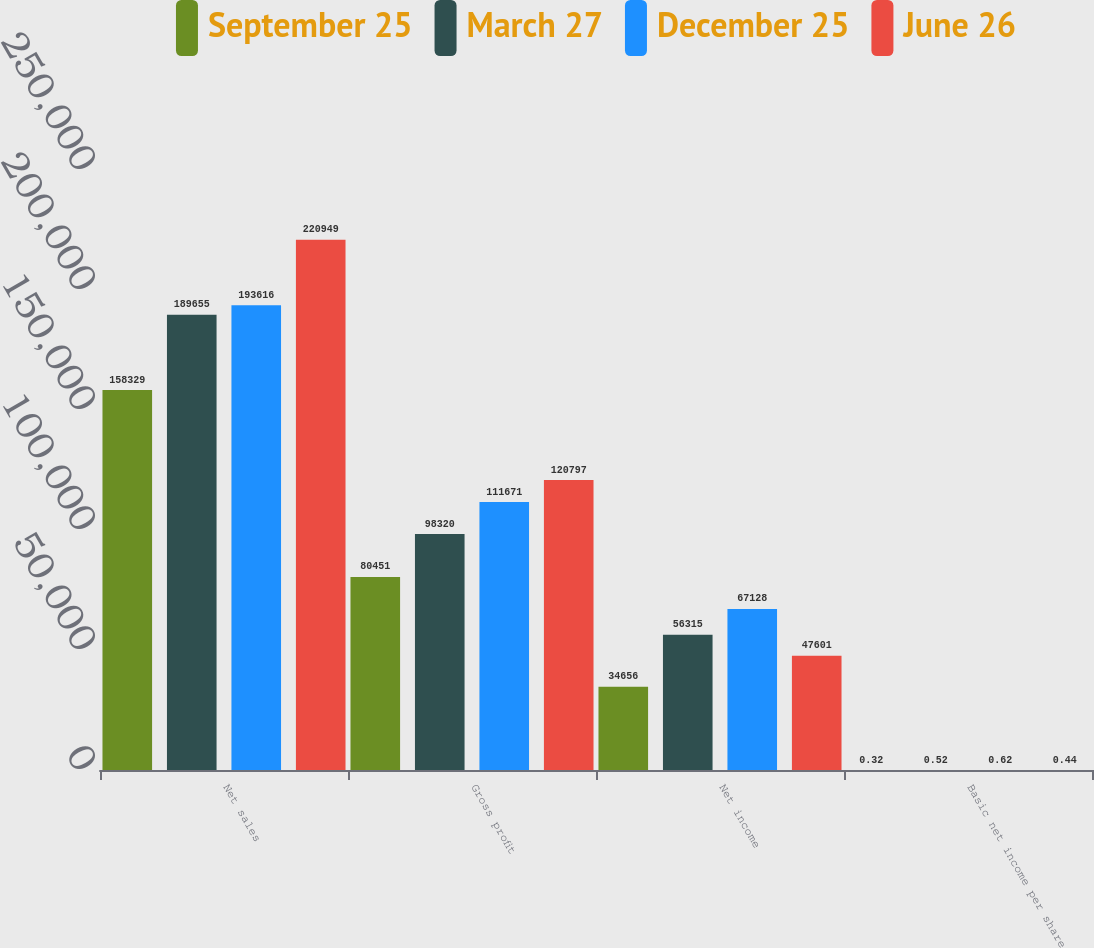Convert chart. <chart><loc_0><loc_0><loc_500><loc_500><stacked_bar_chart><ecel><fcel>Net sales<fcel>Gross profit<fcel>Net income<fcel>Basic net income per share<nl><fcel>September 25<fcel>158329<fcel>80451<fcel>34656<fcel>0.32<nl><fcel>March 27<fcel>189655<fcel>98320<fcel>56315<fcel>0.52<nl><fcel>December 25<fcel>193616<fcel>111671<fcel>67128<fcel>0.62<nl><fcel>June 26<fcel>220949<fcel>120797<fcel>47601<fcel>0.44<nl></chart> 